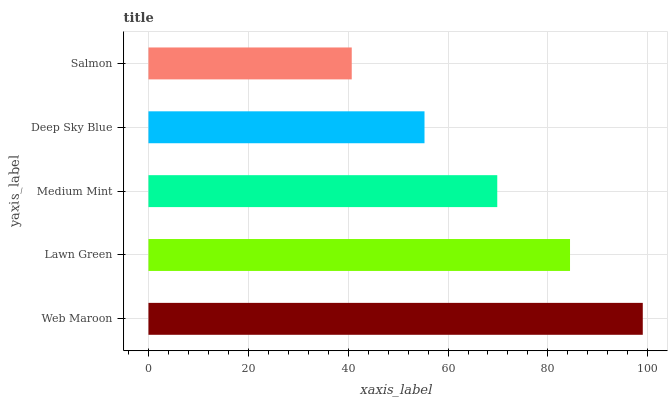Is Salmon the minimum?
Answer yes or no. Yes. Is Web Maroon the maximum?
Answer yes or no. Yes. Is Lawn Green the minimum?
Answer yes or no. No. Is Lawn Green the maximum?
Answer yes or no. No. Is Web Maroon greater than Lawn Green?
Answer yes or no. Yes. Is Lawn Green less than Web Maroon?
Answer yes or no. Yes. Is Lawn Green greater than Web Maroon?
Answer yes or no. No. Is Web Maroon less than Lawn Green?
Answer yes or no. No. Is Medium Mint the high median?
Answer yes or no. Yes. Is Medium Mint the low median?
Answer yes or no. Yes. Is Salmon the high median?
Answer yes or no. No. Is Salmon the low median?
Answer yes or no. No. 